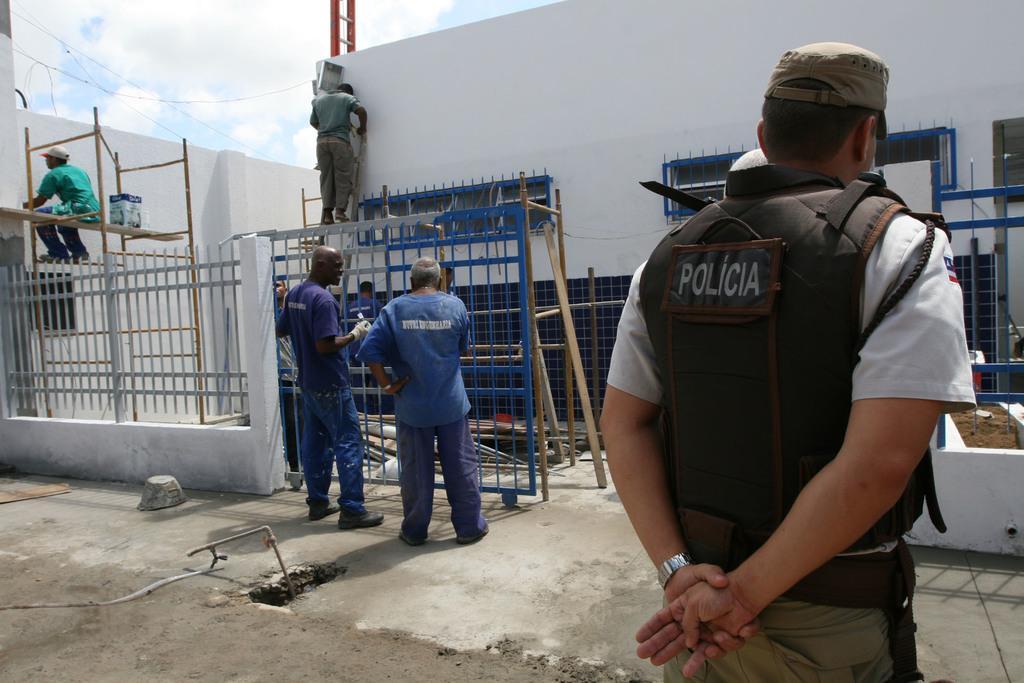Please provide a concise description of this image. In this image we can see people standing on the floor and on the grills. In the background there are buildings and sky with clouds. 